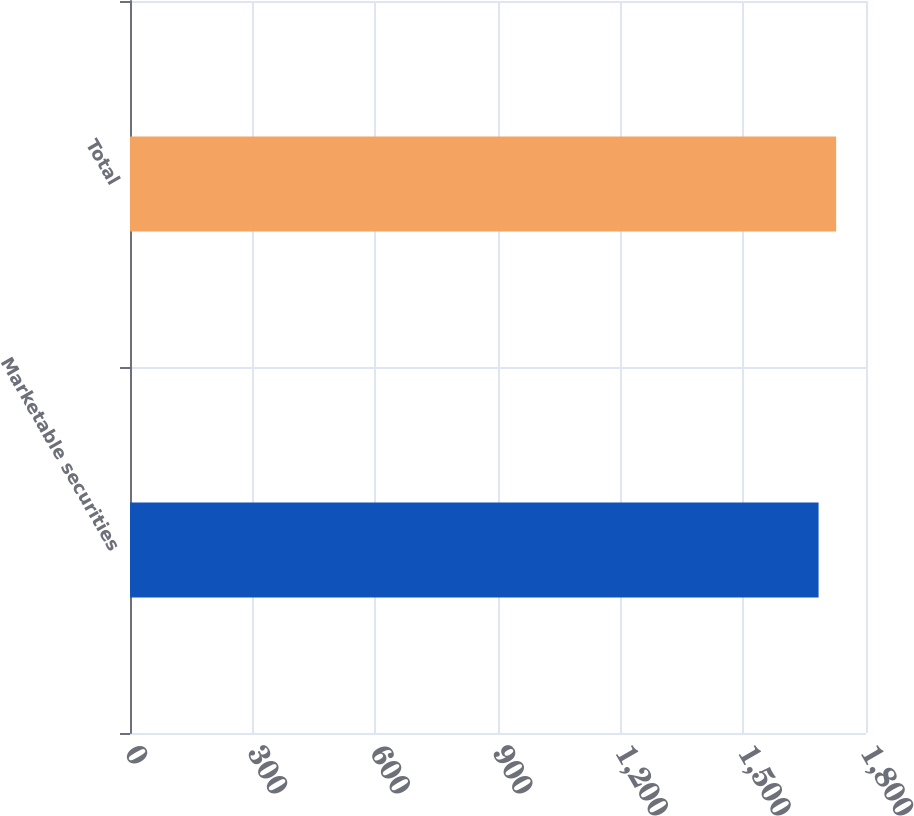Convert chart. <chart><loc_0><loc_0><loc_500><loc_500><bar_chart><fcel>Marketable securities<fcel>Total<nl><fcel>1684<fcel>1727<nl></chart> 